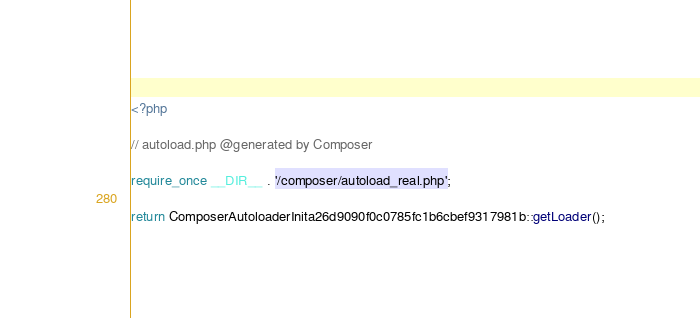<code> <loc_0><loc_0><loc_500><loc_500><_PHP_><?php

// autoload.php @generated by Composer

require_once __DIR__ . '/composer/autoload_real.php';

return ComposerAutoloaderInita26d9090f0c0785fc1b6cbef9317981b::getLoader();
</code> 